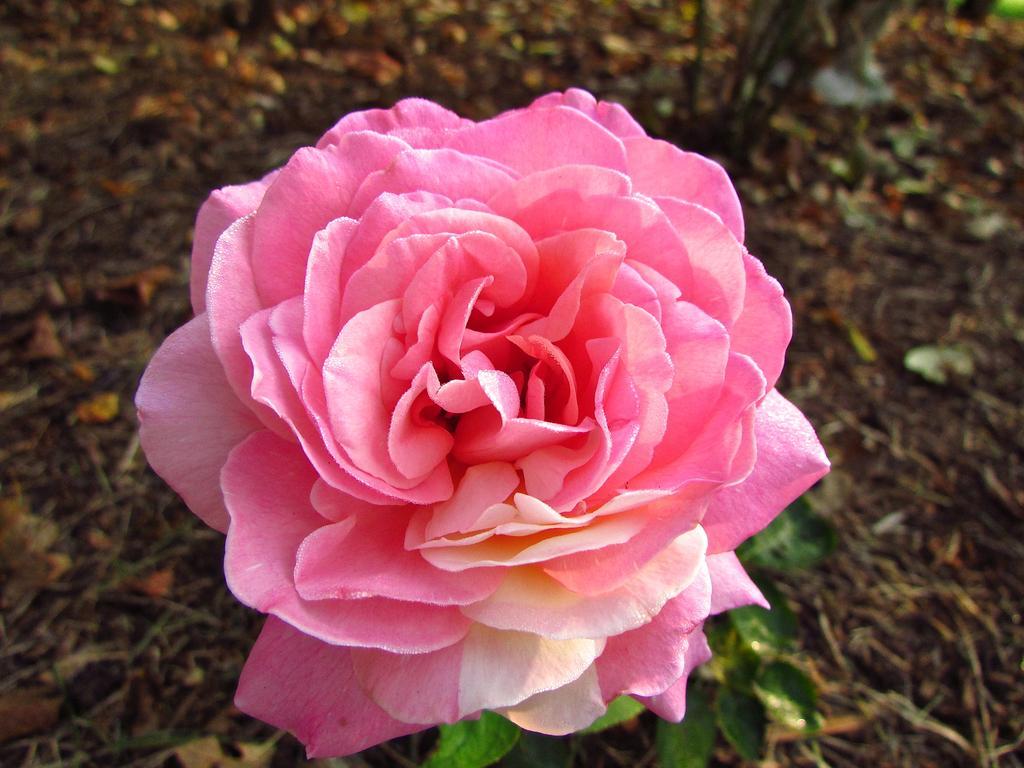Can you describe this image briefly? In this picture there is a rose in the center of the image. 